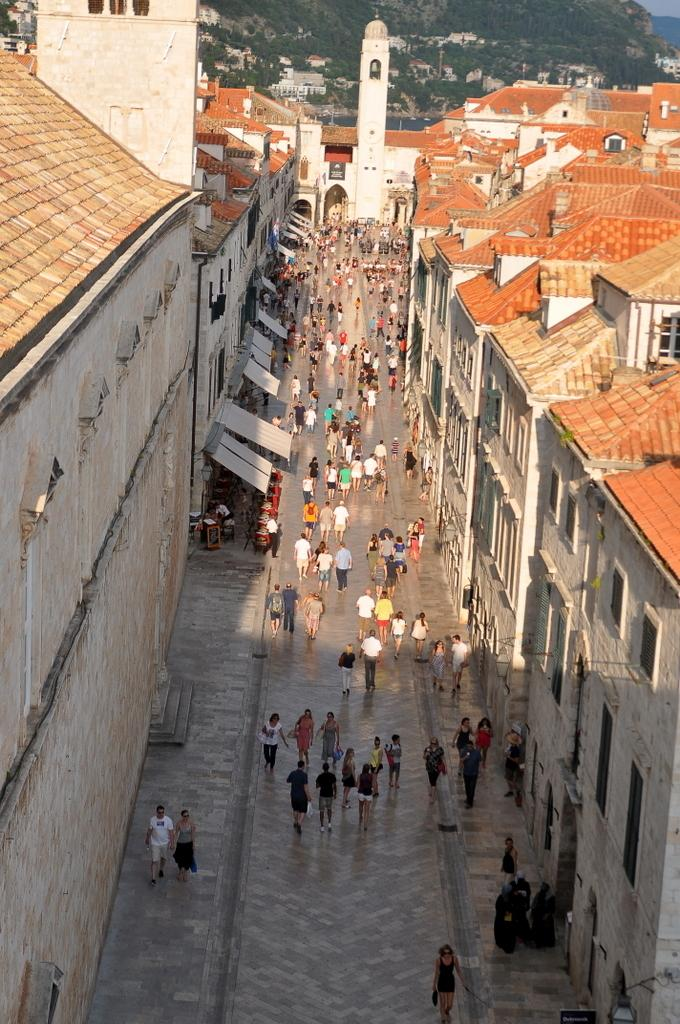Where are the people located in the image? There are people standing on the road and on the footpath in the image. What can be seen on both sides of the road? There are buildings on both sides of the road in the image. What is visible in the background of the image? Hills are visible in the background of the image. What type of milk can be seen being poured from a straw in the image? There is no milk or straw present in the image. 